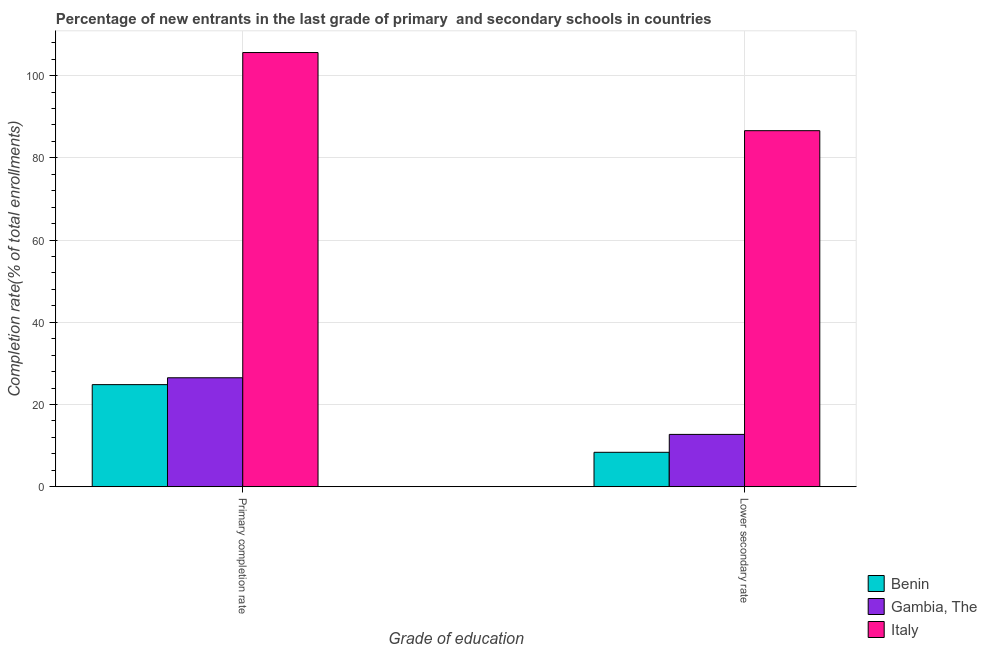How many groups of bars are there?
Your response must be concise. 2. How many bars are there on the 2nd tick from the right?
Offer a terse response. 3. What is the label of the 2nd group of bars from the left?
Your answer should be compact. Lower secondary rate. What is the completion rate in secondary schools in Gambia, The?
Offer a very short reply. 12.73. Across all countries, what is the maximum completion rate in secondary schools?
Offer a very short reply. 86.6. Across all countries, what is the minimum completion rate in primary schools?
Keep it short and to the point. 24.83. In which country was the completion rate in primary schools maximum?
Make the answer very short. Italy. In which country was the completion rate in primary schools minimum?
Offer a terse response. Benin. What is the total completion rate in primary schools in the graph?
Keep it short and to the point. 156.95. What is the difference between the completion rate in primary schools in Benin and that in Italy?
Provide a short and direct response. -80.78. What is the difference between the completion rate in secondary schools in Gambia, The and the completion rate in primary schools in Italy?
Offer a very short reply. -92.88. What is the average completion rate in secondary schools per country?
Offer a terse response. 35.9. What is the difference between the completion rate in primary schools and completion rate in secondary schools in Gambia, The?
Make the answer very short. 13.77. In how many countries, is the completion rate in primary schools greater than 48 %?
Your response must be concise. 1. What is the ratio of the completion rate in secondary schools in Gambia, The to that in Benin?
Provide a succinct answer. 1.52. What does the 2nd bar from the left in Lower secondary rate represents?
Provide a short and direct response. Gambia, The. What does the 1st bar from the right in Lower secondary rate represents?
Offer a very short reply. Italy. How many bars are there?
Provide a short and direct response. 6. What is the difference between two consecutive major ticks on the Y-axis?
Ensure brevity in your answer.  20. Are the values on the major ticks of Y-axis written in scientific E-notation?
Offer a terse response. No. What is the title of the graph?
Provide a short and direct response. Percentage of new entrants in the last grade of primary  and secondary schools in countries. What is the label or title of the X-axis?
Keep it short and to the point. Grade of education. What is the label or title of the Y-axis?
Offer a terse response. Completion rate(% of total enrollments). What is the Completion rate(% of total enrollments) in Benin in Primary completion rate?
Your response must be concise. 24.83. What is the Completion rate(% of total enrollments) in Gambia, The in Primary completion rate?
Your answer should be compact. 26.5. What is the Completion rate(% of total enrollments) of Italy in Primary completion rate?
Make the answer very short. 105.61. What is the Completion rate(% of total enrollments) of Benin in Lower secondary rate?
Offer a terse response. 8.37. What is the Completion rate(% of total enrollments) in Gambia, The in Lower secondary rate?
Your answer should be compact. 12.73. What is the Completion rate(% of total enrollments) in Italy in Lower secondary rate?
Make the answer very short. 86.6. Across all Grade of education, what is the maximum Completion rate(% of total enrollments) in Benin?
Your answer should be compact. 24.83. Across all Grade of education, what is the maximum Completion rate(% of total enrollments) in Gambia, The?
Your response must be concise. 26.5. Across all Grade of education, what is the maximum Completion rate(% of total enrollments) in Italy?
Provide a succinct answer. 105.61. Across all Grade of education, what is the minimum Completion rate(% of total enrollments) of Benin?
Give a very brief answer. 8.37. Across all Grade of education, what is the minimum Completion rate(% of total enrollments) of Gambia, The?
Offer a terse response. 12.73. Across all Grade of education, what is the minimum Completion rate(% of total enrollments) of Italy?
Your response must be concise. 86.6. What is the total Completion rate(% of total enrollments) of Benin in the graph?
Offer a very short reply. 33.21. What is the total Completion rate(% of total enrollments) in Gambia, The in the graph?
Ensure brevity in your answer.  39.23. What is the total Completion rate(% of total enrollments) in Italy in the graph?
Your answer should be compact. 192.22. What is the difference between the Completion rate(% of total enrollments) in Benin in Primary completion rate and that in Lower secondary rate?
Your answer should be very brief. 16.46. What is the difference between the Completion rate(% of total enrollments) of Gambia, The in Primary completion rate and that in Lower secondary rate?
Make the answer very short. 13.77. What is the difference between the Completion rate(% of total enrollments) of Italy in Primary completion rate and that in Lower secondary rate?
Ensure brevity in your answer.  19.01. What is the difference between the Completion rate(% of total enrollments) in Benin in Primary completion rate and the Completion rate(% of total enrollments) in Gambia, The in Lower secondary rate?
Provide a short and direct response. 12.1. What is the difference between the Completion rate(% of total enrollments) in Benin in Primary completion rate and the Completion rate(% of total enrollments) in Italy in Lower secondary rate?
Keep it short and to the point. -61.77. What is the difference between the Completion rate(% of total enrollments) in Gambia, The in Primary completion rate and the Completion rate(% of total enrollments) in Italy in Lower secondary rate?
Keep it short and to the point. -60.1. What is the average Completion rate(% of total enrollments) of Benin per Grade of education?
Offer a very short reply. 16.6. What is the average Completion rate(% of total enrollments) in Gambia, The per Grade of education?
Give a very brief answer. 19.61. What is the average Completion rate(% of total enrollments) of Italy per Grade of education?
Offer a terse response. 96.11. What is the difference between the Completion rate(% of total enrollments) of Benin and Completion rate(% of total enrollments) of Gambia, The in Primary completion rate?
Ensure brevity in your answer.  -1.67. What is the difference between the Completion rate(% of total enrollments) of Benin and Completion rate(% of total enrollments) of Italy in Primary completion rate?
Your response must be concise. -80.78. What is the difference between the Completion rate(% of total enrollments) in Gambia, The and Completion rate(% of total enrollments) in Italy in Primary completion rate?
Your answer should be very brief. -79.11. What is the difference between the Completion rate(% of total enrollments) in Benin and Completion rate(% of total enrollments) in Gambia, The in Lower secondary rate?
Give a very brief answer. -4.36. What is the difference between the Completion rate(% of total enrollments) in Benin and Completion rate(% of total enrollments) in Italy in Lower secondary rate?
Your answer should be very brief. -78.23. What is the difference between the Completion rate(% of total enrollments) in Gambia, The and Completion rate(% of total enrollments) in Italy in Lower secondary rate?
Offer a terse response. -73.88. What is the ratio of the Completion rate(% of total enrollments) of Benin in Primary completion rate to that in Lower secondary rate?
Provide a short and direct response. 2.97. What is the ratio of the Completion rate(% of total enrollments) in Gambia, The in Primary completion rate to that in Lower secondary rate?
Provide a short and direct response. 2.08. What is the ratio of the Completion rate(% of total enrollments) in Italy in Primary completion rate to that in Lower secondary rate?
Your answer should be compact. 1.22. What is the difference between the highest and the second highest Completion rate(% of total enrollments) of Benin?
Ensure brevity in your answer.  16.46. What is the difference between the highest and the second highest Completion rate(% of total enrollments) in Gambia, The?
Provide a succinct answer. 13.77. What is the difference between the highest and the second highest Completion rate(% of total enrollments) of Italy?
Ensure brevity in your answer.  19.01. What is the difference between the highest and the lowest Completion rate(% of total enrollments) in Benin?
Give a very brief answer. 16.46. What is the difference between the highest and the lowest Completion rate(% of total enrollments) of Gambia, The?
Offer a very short reply. 13.77. What is the difference between the highest and the lowest Completion rate(% of total enrollments) in Italy?
Provide a succinct answer. 19.01. 